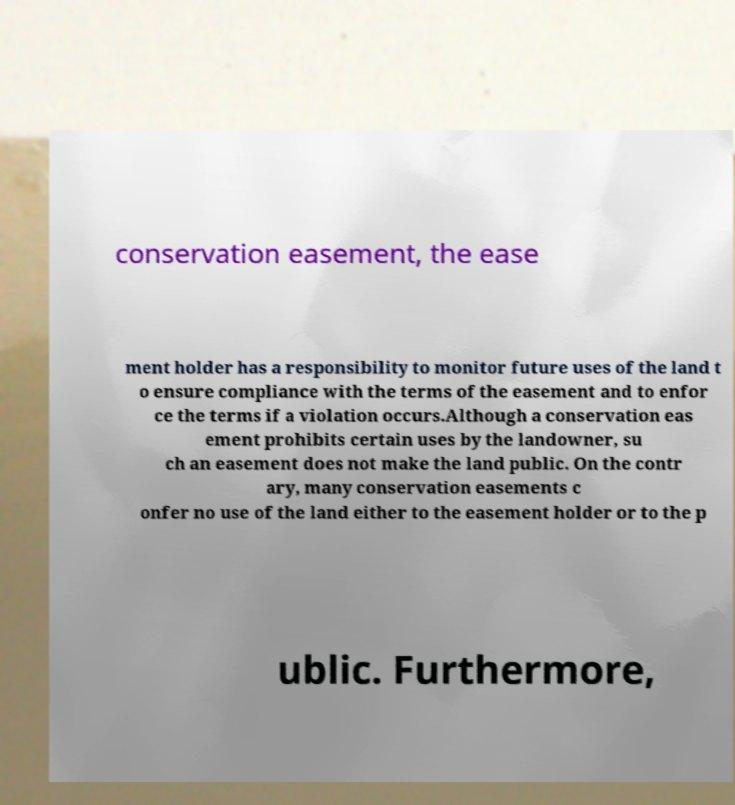Can you read and provide the text displayed in the image?This photo seems to have some interesting text. Can you extract and type it out for me? conservation easement, the ease ment holder has a responsibility to monitor future uses of the land t o ensure compliance with the terms of the easement and to enfor ce the terms if a violation occurs.Although a conservation eas ement prohibits certain uses by the landowner, su ch an easement does not make the land public. On the contr ary, many conservation easements c onfer no use of the land either to the easement holder or to the p ublic. Furthermore, 